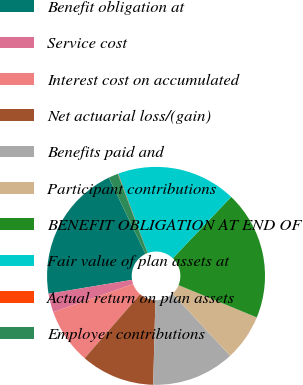Convert chart. <chart><loc_0><loc_0><loc_500><loc_500><pie_chart><fcel>Benefit obligation at<fcel>Service cost<fcel>Interest cost on accumulated<fcel>Net actuarial loss/(gain)<fcel>Benefits paid and<fcel>Participant contributions<fcel>BENEFIT OBLIGATION AT END OF<fcel>Fair value of plan assets at<fcel>Actual return on plan assets<fcel>Employer contributions<nl><fcel>20.49%<fcel>2.78%<fcel>8.23%<fcel>10.95%<fcel>12.32%<fcel>6.87%<fcel>19.12%<fcel>17.76%<fcel>0.06%<fcel>1.42%<nl></chart> 